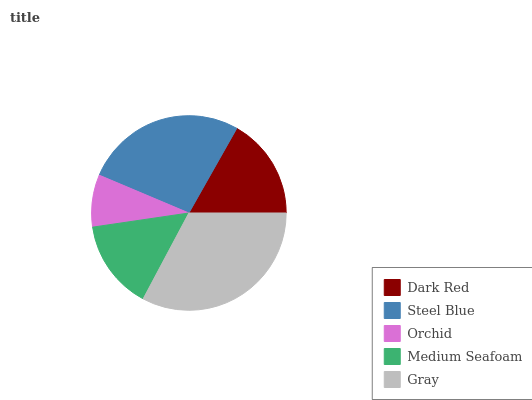Is Orchid the minimum?
Answer yes or no. Yes. Is Gray the maximum?
Answer yes or no. Yes. Is Steel Blue the minimum?
Answer yes or no. No. Is Steel Blue the maximum?
Answer yes or no. No. Is Steel Blue greater than Dark Red?
Answer yes or no. Yes. Is Dark Red less than Steel Blue?
Answer yes or no. Yes. Is Dark Red greater than Steel Blue?
Answer yes or no. No. Is Steel Blue less than Dark Red?
Answer yes or no. No. Is Dark Red the high median?
Answer yes or no. Yes. Is Dark Red the low median?
Answer yes or no. Yes. Is Steel Blue the high median?
Answer yes or no. No. Is Medium Seafoam the low median?
Answer yes or no. No. 